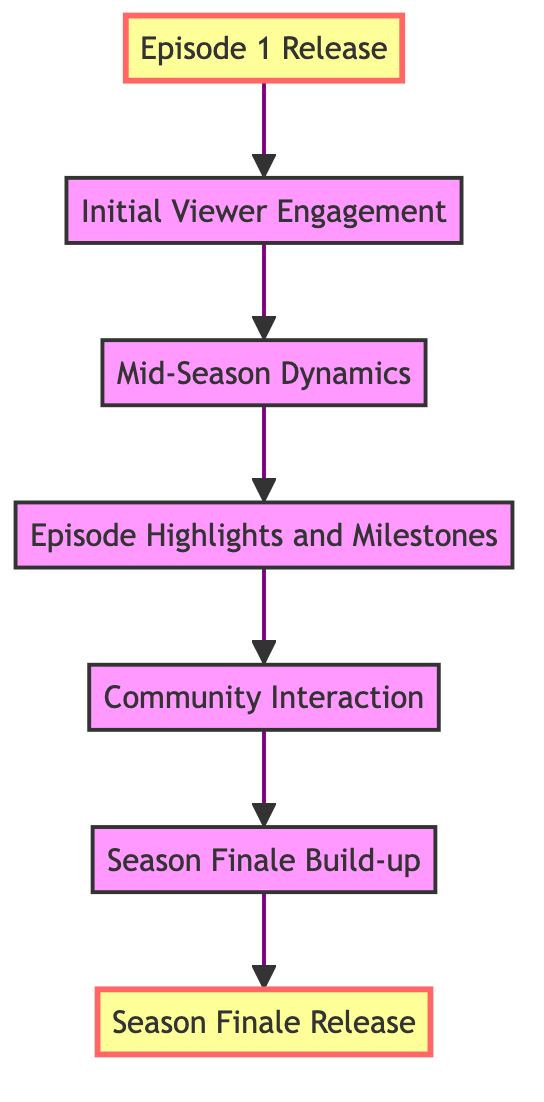What is the first node in the diagram? The diagram starts with "Episode 1 Release," which is the first node at the bottom.
Answer: Episode 1 Release How many nodes are in the flow chart? By counting all the distinct elements listed, there are a total of seven nodes.
Answer: 7 What is the last node in the diagram? The final node at the top is "Season Finale Release."
Answer: Season Finale Release Which two nodes are connected directly above "Mid-Season Dynamics"? The nodes directly connected above "Mid-Season Dynamics" are "Initial Viewer Engagement" and "Episode Highlights and Milestones."
Answer: Initial Viewer Engagement, Episode Highlights and Milestones What describes the transition from "Episode 1 Release" to "Initial Viewer Engagement"? The transition from "Episode 1 Release" to "Initial Viewer Engagement" is characterized by the buzz and early reviews impacting public perception.
Answer: Hype and anticipation How does "Community Interaction" relate to "Episode Highlights and Milestones"? "Community Interaction" follows "Episode Highlights and Milestones," indicating that after special episodes, community discussions grow and become more active.
Answer: Follow-up engagement What leads to the peak engagement in viewer metrics? The highest viewer engagement is reached at "Season Finale Release," driven by real-time reactions and trending discussions.
Answer: Season Finale Release What is the main driver for "Season Finale Build-up"? The anticipation for the finale builds mainly due to teasers, trailers, and narrative developments being shared and discussed online.
Answer: Teasers and trailers Which node is highlighted in the diagram? The highlighted nodes in the diagram are "Episode 1 Release" and "Season Finale Release," indicating significant moments in viewer engagement.
Answer: Episode 1 Release, Season Finale Release 